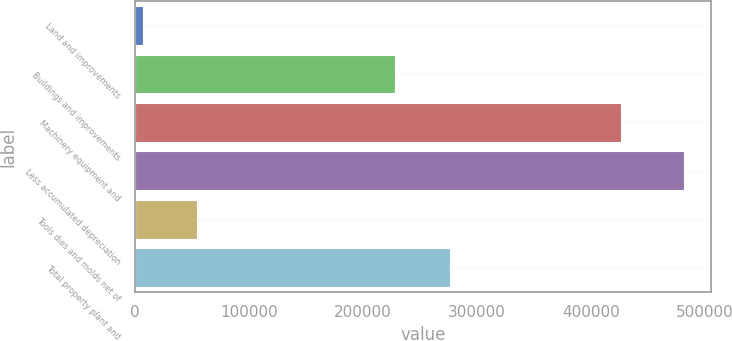Convert chart to OTSL. <chart><loc_0><loc_0><loc_500><loc_500><bar_chart><fcel>Land and improvements<fcel>Buildings and improvements<fcel>Machinery equipment and<fcel>Less accumulated depreciation<fcel>Tools dies and molds net of<fcel>Total property plant and<nl><fcel>7197<fcel>228611<fcel>426992<fcel>481513<fcel>54628.6<fcel>276043<nl></chart> 